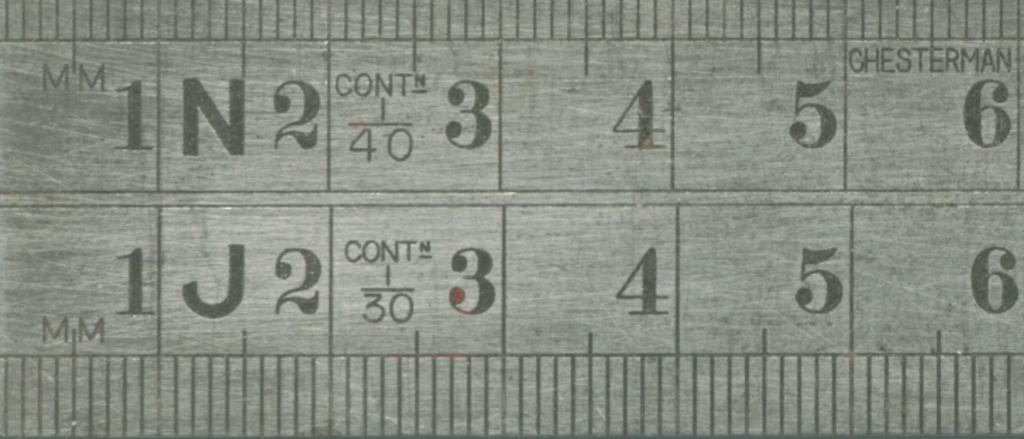<image>
Write a terse but informative summary of the picture. A grey stripe with the numbers 1,2,3,4,5,6 on it and the letters N and J on each row. 